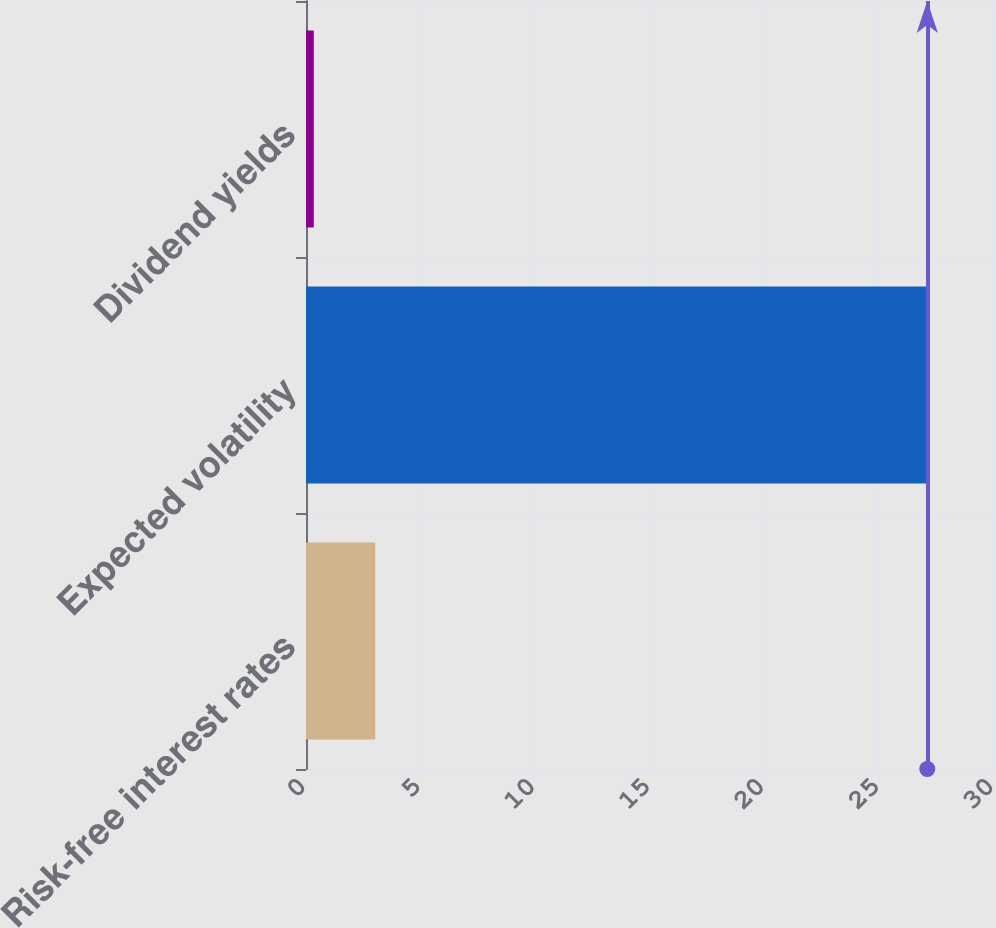Convert chart to OTSL. <chart><loc_0><loc_0><loc_500><loc_500><bar_chart><fcel>Risk-free interest rates<fcel>Expected volatility<fcel>Dividend yields<nl><fcel>3.02<fcel>27.09<fcel>0.34<nl></chart> 